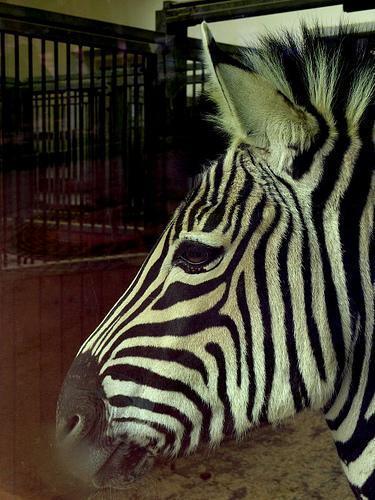How many men are wearing caps?
Give a very brief answer. 0. 